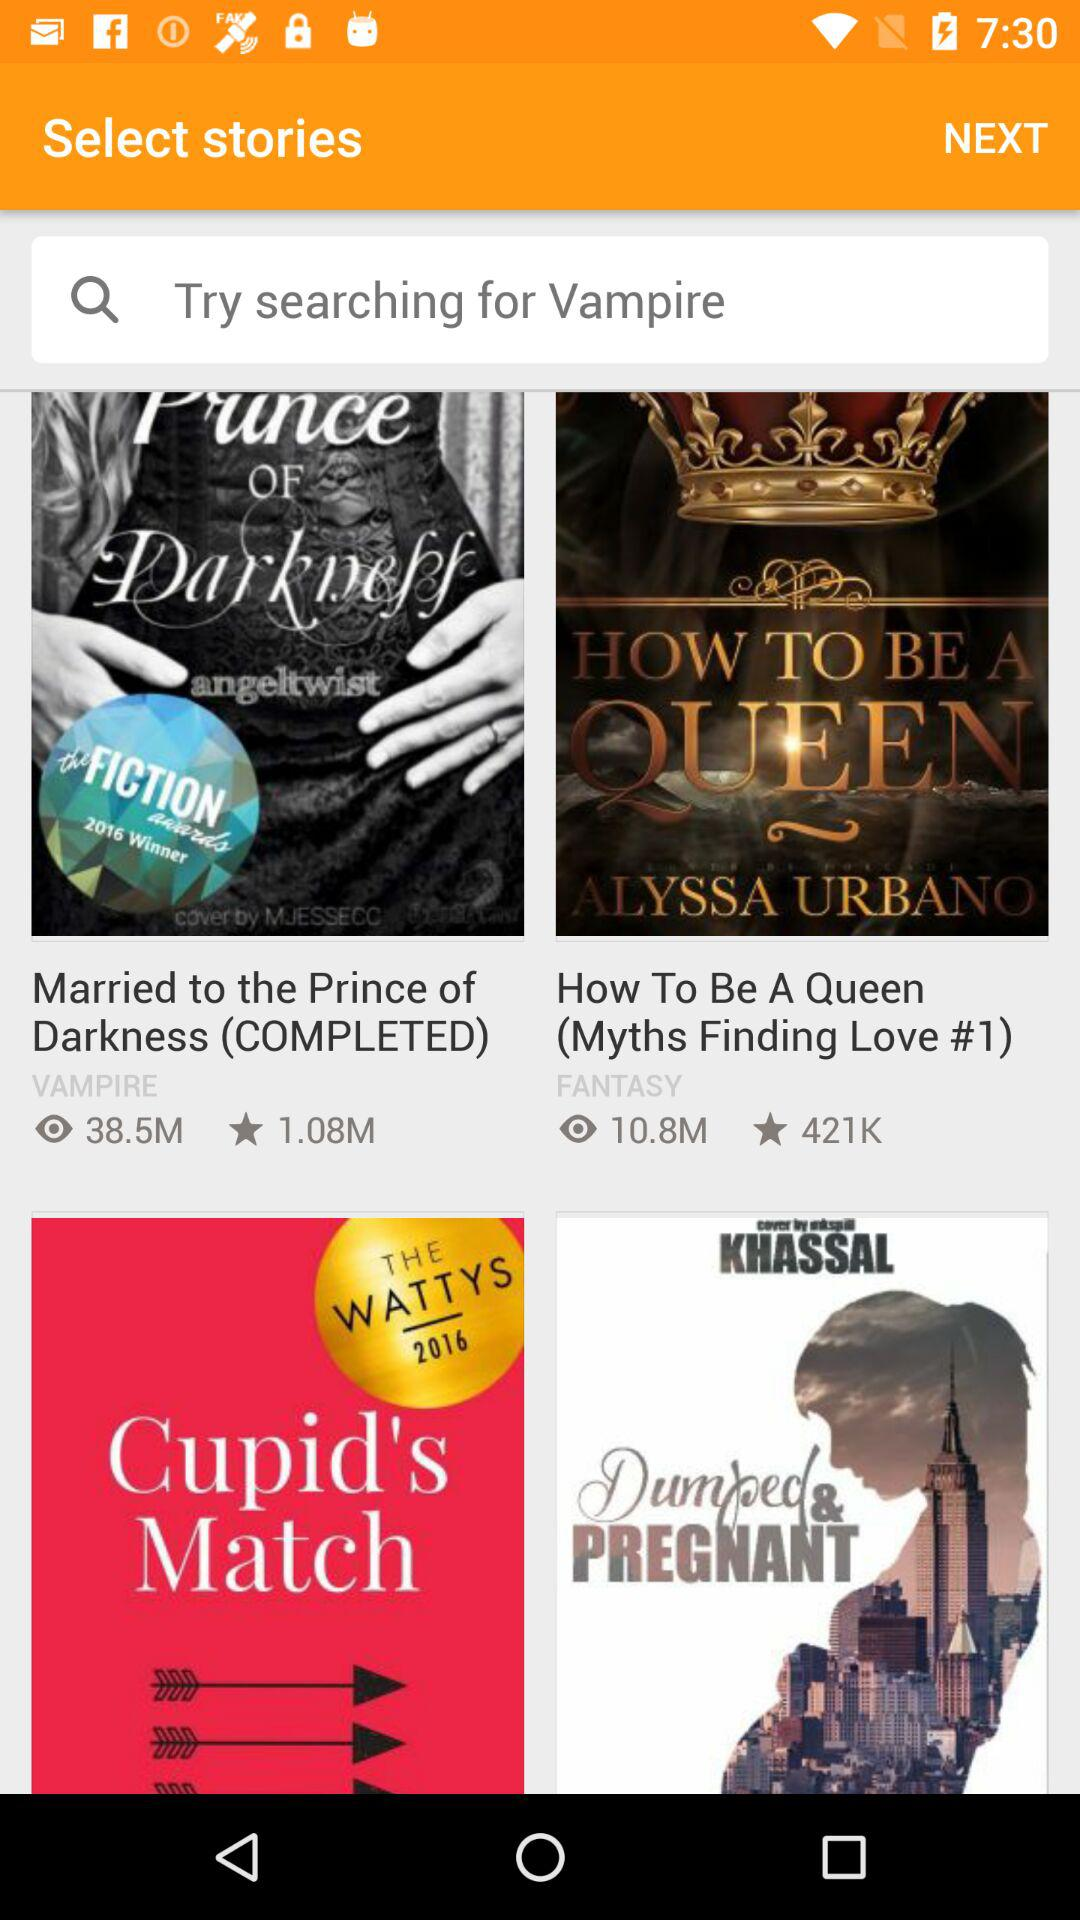What's the total number of people who selected "How To Be A Queen" as their favourite book? There are 421K people who selected "How To Be A Queen" as their favourite book. 